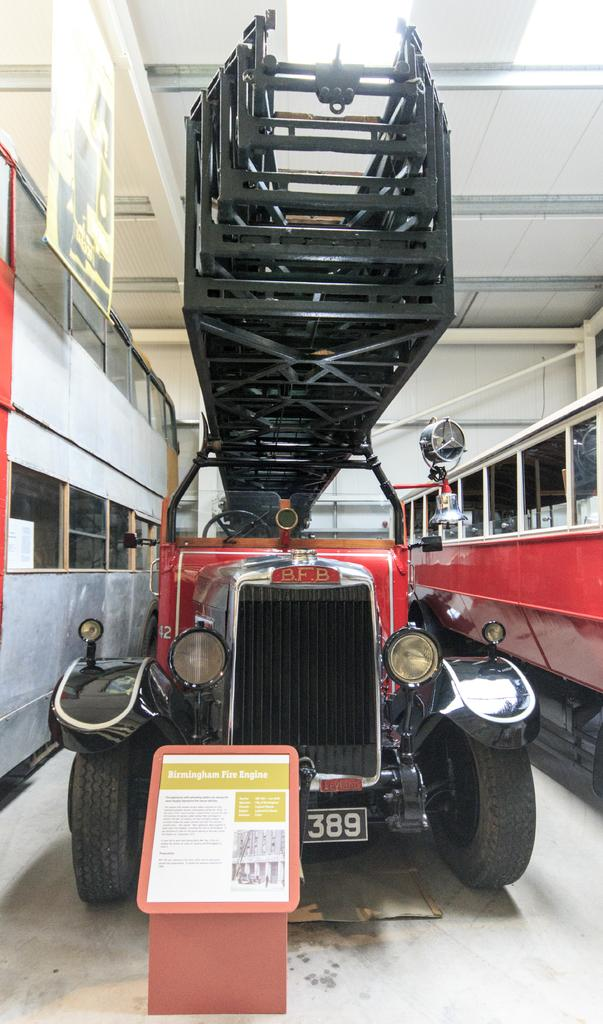What is the main subject in the foreground of the image? There is a vehicle in the foreground of the image. What feature can be seen on both sides of the vehicle? There are glass windows on both sides of the vehicle. What is attached to the bottom side of the vehicle? There is a poster at the bottom side of the vehicle. What covers the top side of the vehicle? There is a roof at the top side of the vehicle. Can you tell me who the fireman is that is helping the vehicle's creator in the image? There is no fireman or vehicle creator present in the image. The image only shows a vehicle with glass windows, a poster, and a roof. 